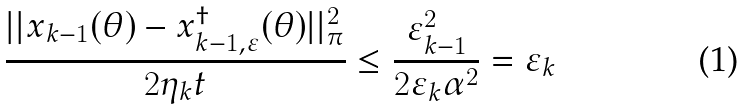<formula> <loc_0><loc_0><loc_500><loc_500>\frac { | | x _ { k - 1 } ( \theta ) - x ^ { \dagger } _ { k - 1 , \varepsilon } ( \theta ) | | _ { \pi } ^ { 2 } } { 2 \eta _ { k } t } \leq \frac { \varepsilon _ { k - 1 } ^ { 2 } } { 2 \varepsilon _ { k } \alpha ^ { 2 } } = \varepsilon _ { k }</formula> 